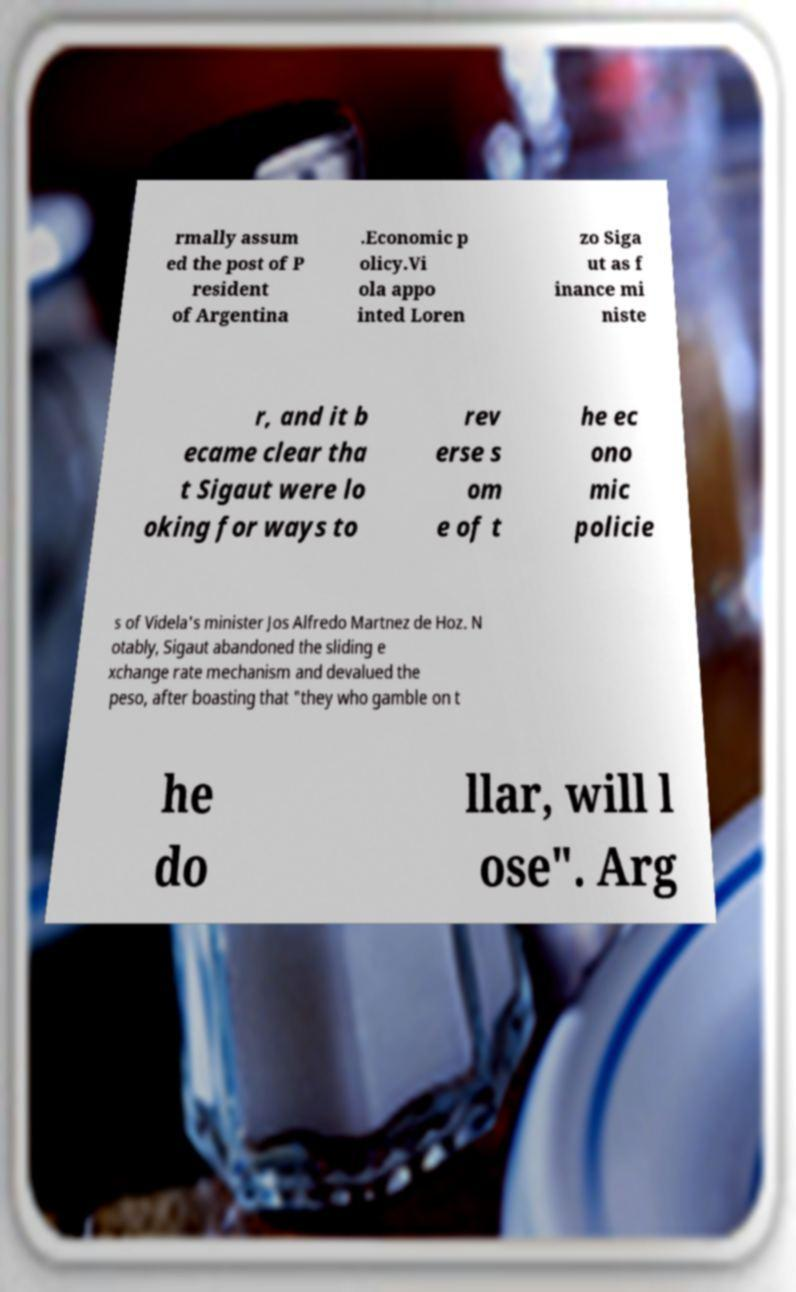Could you assist in decoding the text presented in this image and type it out clearly? rmally assum ed the post of P resident of Argentina .Economic p olicy.Vi ola appo inted Loren zo Siga ut as f inance mi niste r, and it b ecame clear tha t Sigaut were lo oking for ways to rev erse s om e of t he ec ono mic policie s of Videla's minister Jos Alfredo Martnez de Hoz. N otably, Sigaut abandoned the sliding e xchange rate mechanism and devalued the peso, after boasting that "they who gamble on t he do llar, will l ose". Arg 